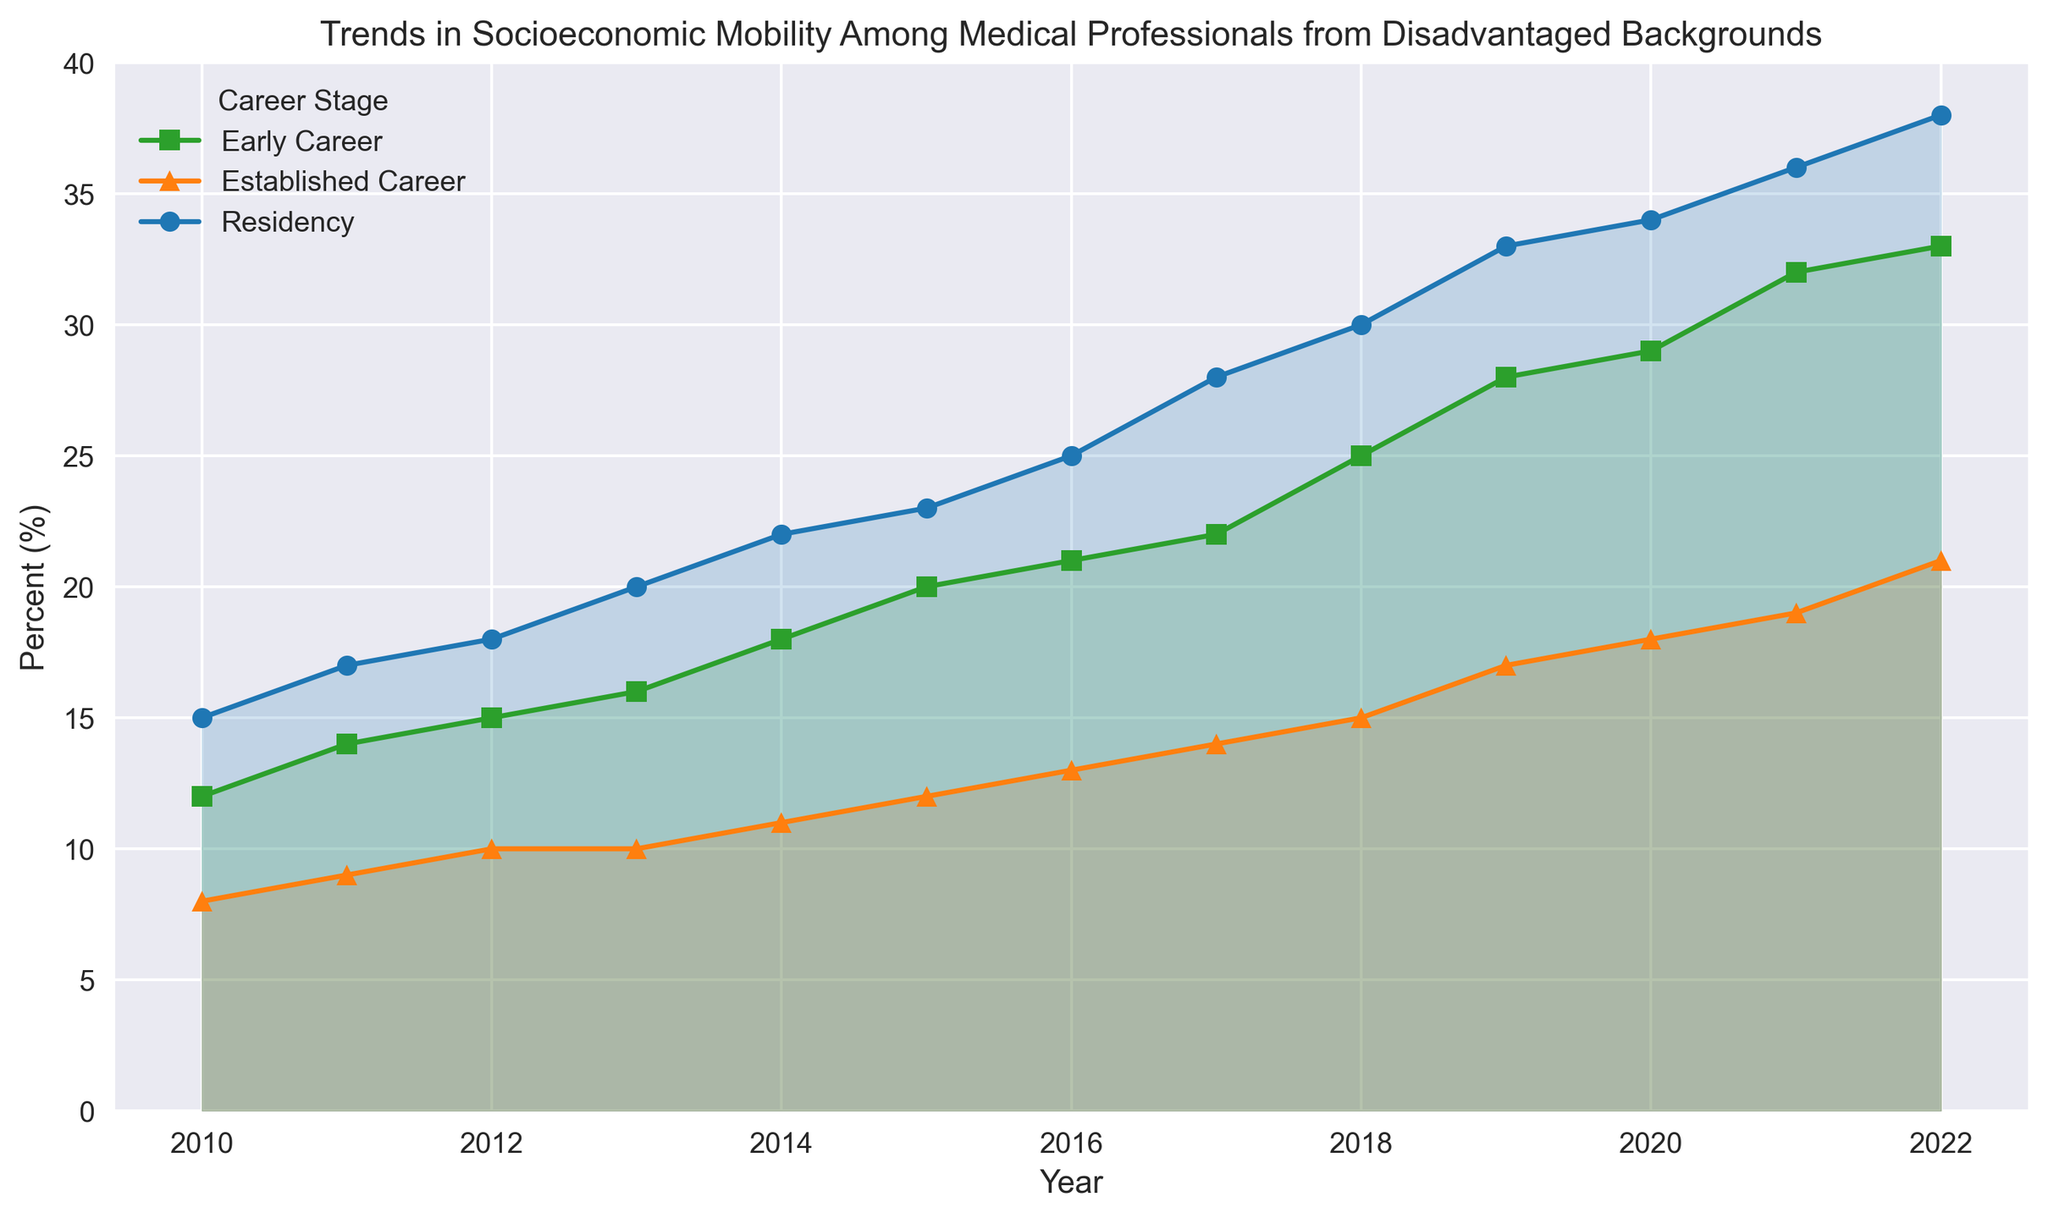What was the percentage of medical professionals in the Residency stage from disadvantaged backgrounds in 2015? Locate the line labeled "Residency" and find the data point for the year 2015. The graph shows a value of 23%.
Answer: 23% Which career stage saw the highest percentage of professionals from disadvantaged backgrounds in 2022? Compare the points for the year 2022 across all three career stages. The Residency stage is the highest at 38%.
Answer: Residency How does the percentage increase from 2010 to 2022 compare between Residency and Established Career stages? Calculate the difference for each stage: Residency (38% - 15% = 23%) and Established Career (21% - 8% = 13%). Residency increased more.
Answer: Residency By how many percentage points did the Early Career stage increase from 2010 to 2022? Subtract the 2010 percentage from the 2022 percentage for Early Career: 33% - 12% = 21%.
Answer: 21% What is the average percentage of professionals from disadvantaged backgrounds in the Established Career stage from 2010 to 2022? Add all the percentages for Established Career and divide by the number of years: (8+9+10+10+11+12+13+14+15+17+18+19+21) / 13 = 13.2%.
Answer: 13.2% Which career stage had the least change over the years? Calculate the change from 2010 to 2022 for each stage: Residency (23%), Early Career (21%), Established Career (13%). Established Career had the least change.
Answer: Established Career Are there any years where the percentage of Early Career professionals surpassed the Residency professionals? Compare the lines for every year from 2010 to 2022. No such intersections are seen.
Answer: No In what year did the Residency stage first reach 30%? Follow the Residency line and see the first instance it crosses the 30% threshold. This happens in 2018.
Answer: 2018 